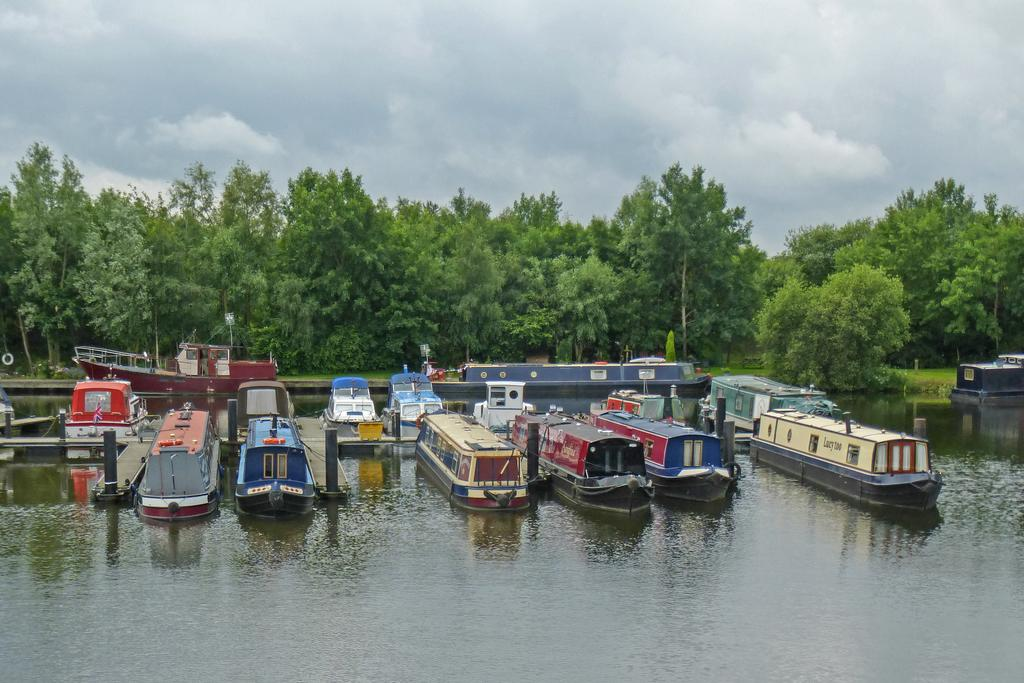What is in the water in the image? There are boats in the water in the image. What can be seen in the background of the image? There are trees and clouds visible in the background of the image. What type of trouble can be seen with the cork in the image? There is no cork present in the image, and therefore no trouble related to a cork can be observed. 